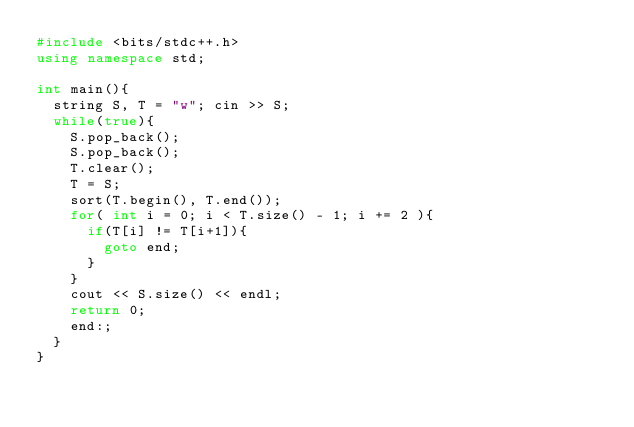Convert code to text. <code><loc_0><loc_0><loc_500><loc_500><_C++_>#include <bits/stdc++.h>
using namespace std;

int main(){
	string S, T = "w"; cin >> S;
	while(true){
		S.pop_back();
		S.pop_back();
		T.clear();
		T = S;
		sort(T.begin(), T.end());
		for( int i = 0; i < T.size() - 1; i += 2 ){
			if(T[i] != T[i+1]){
				goto end; 
			}
		}
		cout << S.size() << endl;
		return 0;
		end:;
	}
}</code> 